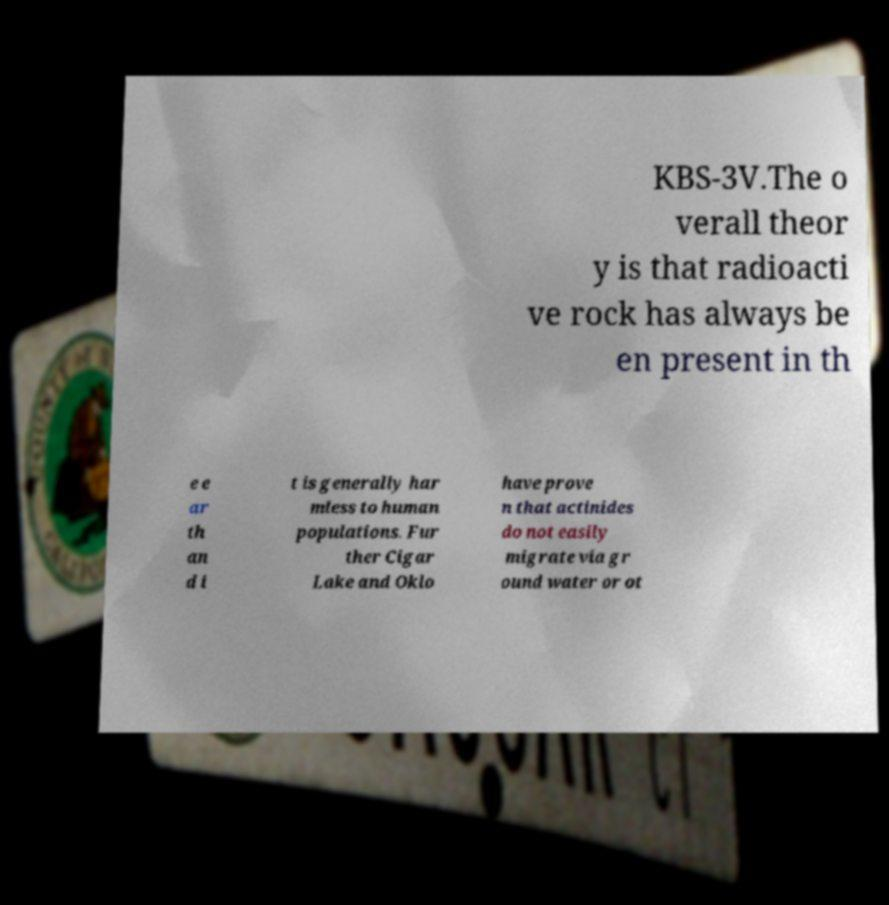Please read and relay the text visible in this image. What does it say? KBS-3V.The o verall theor y is that radioacti ve rock has always be en present in th e e ar th an d i t is generally har mless to human populations. Fur ther Cigar Lake and Oklo have prove n that actinides do not easily migrate via gr ound water or ot 